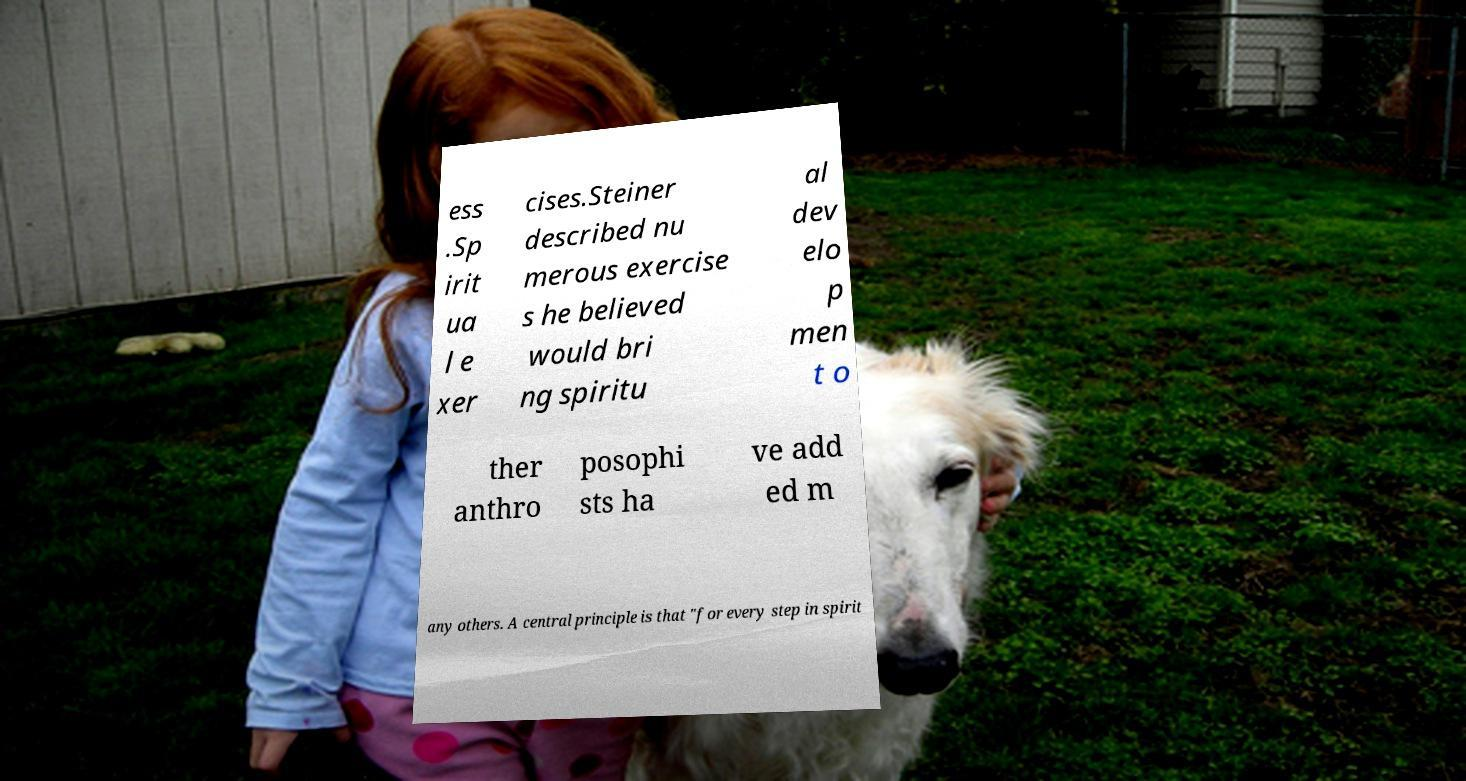Please read and relay the text visible in this image. What does it say? ess .Sp irit ua l e xer cises.Steiner described nu merous exercise s he believed would bri ng spiritu al dev elo p men t o ther anthro posophi sts ha ve add ed m any others. A central principle is that "for every step in spirit 